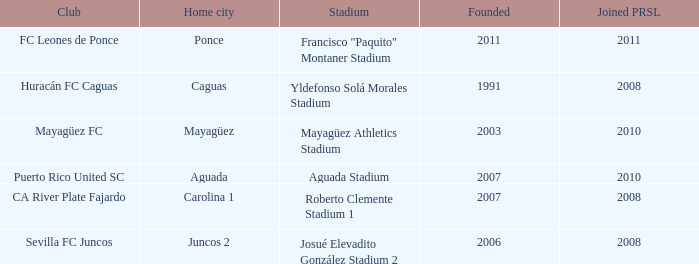What is the organization established prior to 2007, became a member of prsl in 2008, and has yldefonso solá morales stadium as their venue? Huracán FC Caguas. 